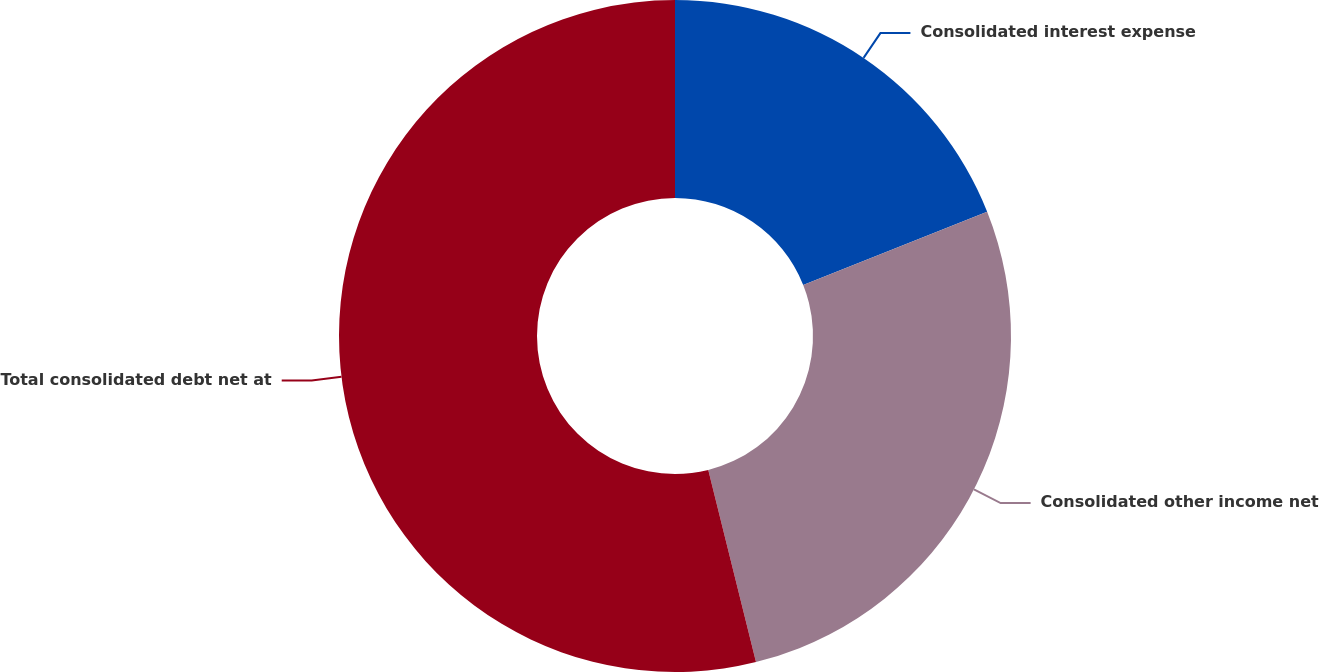Convert chart to OTSL. <chart><loc_0><loc_0><loc_500><loc_500><pie_chart><fcel>Consolidated interest expense<fcel>Consolidated other income net<fcel>Total consolidated debt net at<nl><fcel>18.97%<fcel>27.16%<fcel>53.88%<nl></chart> 